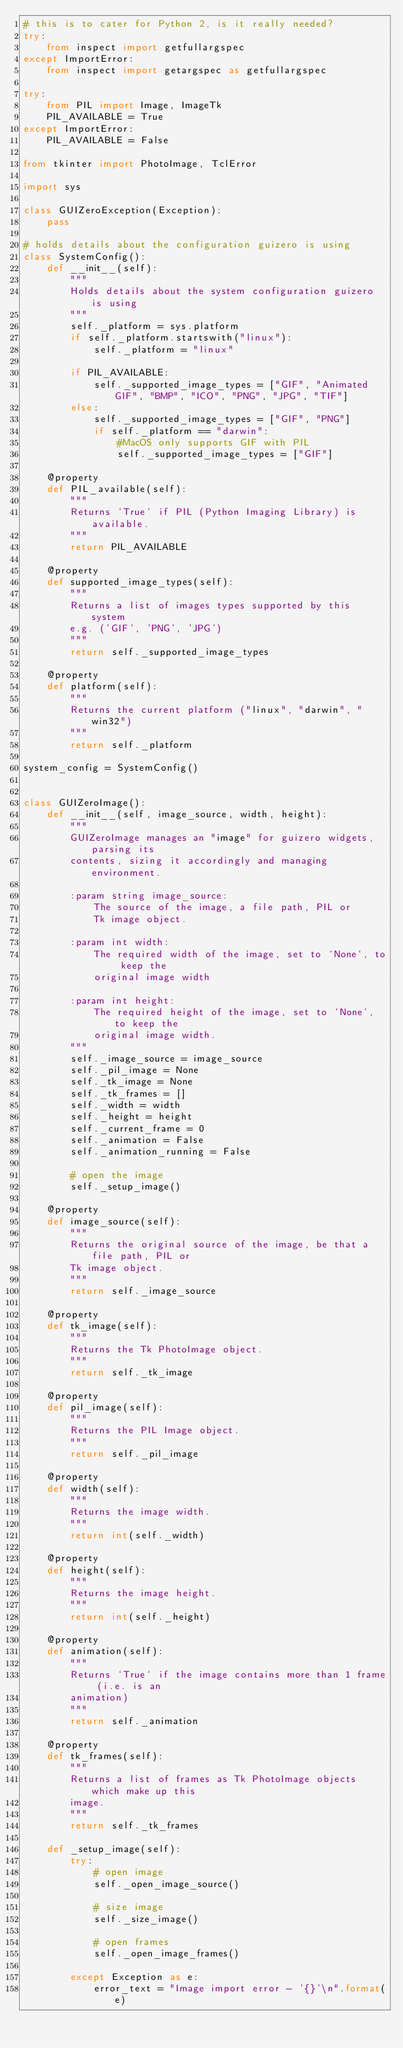Convert code to text. <code><loc_0><loc_0><loc_500><loc_500><_Python_># this is to cater for Python 2, is it really needed?
try:
    from inspect import getfullargspec
except ImportError:
    from inspect import getargspec as getfullargspec

try:
    from PIL import Image, ImageTk
    PIL_AVAILABLE = True
except ImportError:
    PIL_AVAILABLE = False

from tkinter import PhotoImage, TclError

import sys

class GUIZeroException(Exception):
    pass

# holds details about the configuration guizero is using
class SystemConfig():
    def __init__(self):
        """
        Holds details about the system configuration guizero is using
        """
        self._platform = sys.platform
        if self._platform.startswith("linux"):
            self._platform = "linux"

        if PIL_AVAILABLE:
            self._supported_image_types = ["GIF", "Animated GIF", "BMP", "ICO", "PNG", "JPG", "TIF"]
        else:
            self._supported_image_types = ["GIF", "PNG"]
            if self._platform == "darwin":
                #MacOS only supports GIF with PIL
                self._supported_image_types = ["GIF"]

    @property
    def PIL_available(self):
        """
        Returns `True` if PIL (Python Imaging Library) is available.
        """
        return PIL_AVAILABLE

    @property
    def supported_image_types(self):
        """
        Returns a list of images types supported by this system
        e.g. ('GIF', 'PNG', 'JPG')
        """
        return self._supported_image_types

    @property
    def platform(self):
        """
        Returns the current platform ("linux", "darwin", "win32")
        """
        return self._platform

system_config = SystemConfig()


class GUIZeroImage():
    def __init__(self, image_source, width, height):
        """
        GUIZeroImage manages an "image" for guizero widgets, parsing its
        contents, sizing it accordingly and managing environment.

        :param string image_source:
            The source of the image, a file path, PIL or
            Tk image object.

        :param int width:
            The required width of the image, set to `None`, to keep the
            original image width

        :param int height:
            The required height of the image, set to `None`, to keep the
            original image width.
        """
        self._image_source = image_source
        self._pil_image = None
        self._tk_image = None
        self._tk_frames = []
        self._width = width
        self._height = height
        self._current_frame = 0
        self._animation = False
        self._animation_running = False

        # open the image
        self._setup_image()

    @property
    def image_source(self):
        """
        Returns the original source of the image, be that a file path, PIL or
        Tk image object.
        """
        return self._image_source

    @property
    def tk_image(self):
        """
        Returns the Tk PhotoImage object.
        """
        return self._tk_image

    @property
    def pil_image(self):
        """
        Returns the PIL Image object.
        """
        return self._pil_image

    @property
    def width(self):
        """
        Returns the image width.
        """
        return int(self._width)

    @property
    def height(self):
        """
        Returns the image height.
        """
        return int(self._height)

    @property
    def animation(self):
        """
        Returns `True` if the image contains more than 1 frame (i.e. is an
        animation)
        """
        return self._animation

    @property
    def tk_frames(self):
        """
        Returns a list of frames as Tk PhotoImage objects which make up this
        image.
        """
        return self._tk_frames

    def _setup_image(self):
        try:
            # open image
            self._open_image_source()

            # size image
            self._size_image()

            # open frames
            self._open_image_frames()

        except Exception as e:
            error_text = "Image import error - '{}'\n".format(e)</code> 